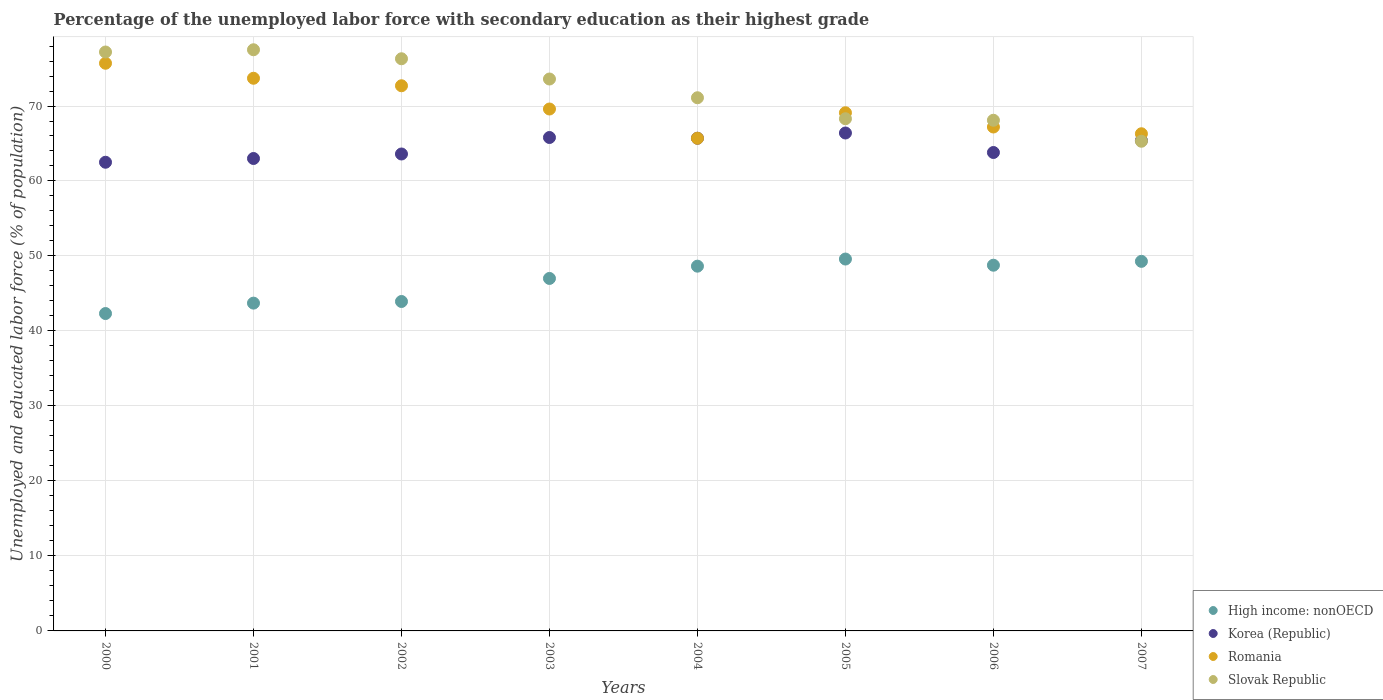What is the percentage of the unemployed labor force with secondary education in Romania in 2005?
Your answer should be very brief. 69.1. Across all years, what is the maximum percentage of the unemployed labor force with secondary education in Romania?
Offer a terse response. 75.7. Across all years, what is the minimum percentage of the unemployed labor force with secondary education in High income: nonOECD?
Your response must be concise. 42.32. In which year was the percentage of the unemployed labor force with secondary education in Korea (Republic) maximum?
Make the answer very short. 2005. In which year was the percentage of the unemployed labor force with secondary education in Romania minimum?
Provide a short and direct response. 2004. What is the total percentage of the unemployed labor force with secondary education in High income: nonOECD in the graph?
Provide a short and direct response. 373.26. What is the difference between the percentage of the unemployed labor force with secondary education in Romania in 2002 and that in 2007?
Your answer should be very brief. 6.4. What is the difference between the percentage of the unemployed labor force with secondary education in Slovak Republic in 2003 and the percentage of the unemployed labor force with secondary education in Korea (Republic) in 2000?
Give a very brief answer. 11.1. What is the average percentage of the unemployed labor force with secondary education in Korea (Republic) per year?
Keep it short and to the point. 64.53. In the year 2005, what is the difference between the percentage of the unemployed labor force with secondary education in Romania and percentage of the unemployed labor force with secondary education in Korea (Republic)?
Offer a terse response. 2.7. What is the ratio of the percentage of the unemployed labor force with secondary education in Korea (Republic) in 2001 to that in 2004?
Ensure brevity in your answer.  0.96. What is the difference between the highest and the second highest percentage of the unemployed labor force with secondary education in Korea (Republic)?
Your answer should be very brief. 0.6. Is the sum of the percentage of the unemployed labor force with secondary education in Romania in 2000 and 2003 greater than the maximum percentage of the unemployed labor force with secondary education in Slovak Republic across all years?
Provide a succinct answer. Yes. Is it the case that in every year, the sum of the percentage of the unemployed labor force with secondary education in Korea (Republic) and percentage of the unemployed labor force with secondary education in High income: nonOECD  is greater than the percentage of the unemployed labor force with secondary education in Romania?
Provide a short and direct response. Yes. Is the percentage of the unemployed labor force with secondary education in Romania strictly greater than the percentage of the unemployed labor force with secondary education in Korea (Republic) over the years?
Your answer should be compact. No. Is the percentage of the unemployed labor force with secondary education in Slovak Republic strictly less than the percentage of the unemployed labor force with secondary education in Romania over the years?
Give a very brief answer. No. How many dotlines are there?
Offer a terse response. 4. What is the difference between two consecutive major ticks on the Y-axis?
Provide a short and direct response. 10. Are the values on the major ticks of Y-axis written in scientific E-notation?
Offer a very short reply. No. What is the title of the graph?
Keep it short and to the point. Percentage of the unemployed labor force with secondary education as their highest grade. What is the label or title of the Y-axis?
Offer a very short reply. Unemployed and educated labor force (% of population). What is the Unemployed and educated labor force (% of population) in High income: nonOECD in 2000?
Make the answer very short. 42.32. What is the Unemployed and educated labor force (% of population) of Korea (Republic) in 2000?
Offer a terse response. 62.5. What is the Unemployed and educated labor force (% of population) in Romania in 2000?
Make the answer very short. 75.7. What is the Unemployed and educated labor force (% of population) in Slovak Republic in 2000?
Provide a short and direct response. 77.2. What is the Unemployed and educated labor force (% of population) in High income: nonOECD in 2001?
Ensure brevity in your answer.  43.71. What is the Unemployed and educated labor force (% of population) in Korea (Republic) in 2001?
Give a very brief answer. 63. What is the Unemployed and educated labor force (% of population) of Romania in 2001?
Give a very brief answer. 73.7. What is the Unemployed and educated labor force (% of population) of Slovak Republic in 2001?
Keep it short and to the point. 77.5. What is the Unemployed and educated labor force (% of population) in High income: nonOECD in 2002?
Your response must be concise. 43.93. What is the Unemployed and educated labor force (% of population) of Korea (Republic) in 2002?
Your response must be concise. 63.6. What is the Unemployed and educated labor force (% of population) in Romania in 2002?
Your answer should be compact. 72.7. What is the Unemployed and educated labor force (% of population) in Slovak Republic in 2002?
Make the answer very short. 76.3. What is the Unemployed and educated labor force (% of population) in High income: nonOECD in 2003?
Ensure brevity in your answer.  47. What is the Unemployed and educated labor force (% of population) of Korea (Republic) in 2003?
Keep it short and to the point. 65.8. What is the Unemployed and educated labor force (% of population) in Romania in 2003?
Provide a short and direct response. 69.6. What is the Unemployed and educated labor force (% of population) of Slovak Republic in 2003?
Offer a very short reply. 73.6. What is the Unemployed and educated labor force (% of population) of High income: nonOECD in 2004?
Provide a succinct answer. 48.64. What is the Unemployed and educated labor force (% of population) of Korea (Republic) in 2004?
Ensure brevity in your answer.  65.7. What is the Unemployed and educated labor force (% of population) of Romania in 2004?
Make the answer very short. 65.7. What is the Unemployed and educated labor force (% of population) in Slovak Republic in 2004?
Ensure brevity in your answer.  71.1. What is the Unemployed and educated labor force (% of population) of High income: nonOECD in 2005?
Offer a very short reply. 49.59. What is the Unemployed and educated labor force (% of population) in Korea (Republic) in 2005?
Offer a terse response. 66.4. What is the Unemployed and educated labor force (% of population) of Romania in 2005?
Offer a very short reply. 69.1. What is the Unemployed and educated labor force (% of population) in Slovak Republic in 2005?
Offer a terse response. 68.3. What is the Unemployed and educated labor force (% of population) of High income: nonOECD in 2006?
Offer a terse response. 48.77. What is the Unemployed and educated labor force (% of population) of Korea (Republic) in 2006?
Give a very brief answer. 63.8. What is the Unemployed and educated labor force (% of population) in Romania in 2006?
Offer a very short reply. 67.2. What is the Unemployed and educated labor force (% of population) of Slovak Republic in 2006?
Offer a very short reply. 68.1. What is the Unemployed and educated labor force (% of population) in High income: nonOECD in 2007?
Offer a terse response. 49.28. What is the Unemployed and educated labor force (% of population) in Korea (Republic) in 2007?
Your response must be concise. 65.4. What is the Unemployed and educated labor force (% of population) of Romania in 2007?
Keep it short and to the point. 66.3. What is the Unemployed and educated labor force (% of population) of Slovak Republic in 2007?
Offer a very short reply. 65.3. Across all years, what is the maximum Unemployed and educated labor force (% of population) of High income: nonOECD?
Give a very brief answer. 49.59. Across all years, what is the maximum Unemployed and educated labor force (% of population) of Korea (Republic)?
Your answer should be compact. 66.4. Across all years, what is the maximum Unemployed and educated labor force (% of population) in Romania?
Ensure brevity in your answer.  75.7. Across all years, what is the maximum Unemployed and educated labor force (% of population) in Slovak Republic?
Ensure brevity in your answer.  77.5. Across all years, what is the minimum Unemployed and educated labor force (% of population) of High income: nonOECD?
Make the answer very short. 42.32. Across all years, what is the minimum Unemployed and educated labor force (% of population) of Korea (Republic)?
Provide a short and direct response. 62.5. Across all years, what is the minimum Unemployed and educated labor force (% of population) in Romania?
Provide a short and direct response. 65.7. Across all years, what is the minimum Unemployed and educated labor force (% of population) in Slovak Republic?
Offer a terse response. 65.3. What is the total Unemployed and educated labor force (% of population) in High income: nonOECD in the graph?
Make the answer very short. 373.26. What is the total Unemployed and educated labor force (% of population) of Korea (Republic) in the graph?
Offer a very short reply. 516.2. What is the total Unemployed and educated labor force (% of population) of Romania in the graph?
Offer a very short reply. 560. What is the total Unemployed and educated labor force (% of population) of Slovak Republic in the graph?
Keep it short and to the point. 577.4. What is the difference between the Unemployed and educated labor force (% of population) of High income: nonOECD in 2000 and that in 2001?
Provide a succinct answer. -1.39. What is the difference between the Unemployed and educated labor force (% of population) in Korea (Republic) in 2000 and that in 2001?
Your answer should be compact. -0.5. What is the difference between the Unemployed and educated labor force (% of population) of Romania in 2000 and that in 2001?
Provide a succinct answer. 2. What is the difference between the Unemployed and educated labor force (% of population) of Slovak Republic in 2000 and that in 2001?
Your answer should be very brief. -0.3. What is the difference between the Unemployed and educated labor force (% of population) of High income: nonOECD in 2000 and that in 2002?
Your answer should be compact. -1.61. What is the difference between the Unemployed and educated labor force (% of population) of Korea (Republic) in 2000 and that in 2002?
Your answer should be compact. -1.1. What is the difference between the Unemployed and educated labor force (% of population) of Romania in 2000 and that in 2002?
Offer a very short reply. 3. What is the difference between the Unemployed and educated labor force (% of population) in High income: nonOECD in 2000 and that in 2003?
Your answer should be very brief. -4.68. What is the difference between the Unemployed and educated labor force (% of population) of Romania in 2000 and that in 2003?
Make the answer very short. 6.1. What is the difference between the Unemployed and educated labor force (% of population) of High income: nonOECD in 2000 and that in 2004?
Give a very brief answer. -6.32. What is the difference between the Unemployed and educated labor force (% of population) of Korea (Republic) in 2000 and that in 2004?
Keep it short and to the point. -3.2. What is the difference between the Unemployed and educated labor force (% of population) of Romania in 2000 and that in 2004?
Provide a succinct answer. 10. What is the difference between the Unemployed and educated labor force (% of population) of Slovak Republic in 2000 and that in 2004?
Ensure brevity in your answer.  6.1. What is the difference between the Unemployed and educated labor force (% of population) of High income: nonOECD in 2000 and that in 2005?
Keep it short and to the point. -7.27. What is the difference between the Unemployed and educated labor force (% of population) of Korea (Republic) in 2000 and that in 2005?
Offer a very short reply. -3.9. What is the difference between the Unemployed and educated labor force (% of population) in High income: nonOECD in 2000 and that in 2006?
Make the answer very short. -6.44. What is the difference between the Unemployed and educated labor force (% of population) in High income: nonOECD in 2000 and that in 2007?
Keep it short and to the point. -6.96. What is the difference between the Unemployed and educated labor force (% of population) in Korea (Republic) in 2000 and that in 2007?
Offer a terse response. -2.9. What is the difference between the Unemployed and educated labor force (% of population) of Slovak Republic in 2000 and that in 2007?
Your response must be concise. 11.9. What is the difference between the Unemployed and educated labor force (% of population) in High income: nonOECD in 2001 and that in 2002?
Offer a terse response. -0.22. What is the difference between the Unemployed and educated labor force (% of population) in Korea (Republic) in 2001 and that in 2002?
Your answer should be very brief. -0.6. What is the difference between the Unemployed and educated labor force (% of population) of Romania in 2001 and that in 2002?
Your answer should be very brief. 1. What is the difference between the Unemployed and educated labor force (% of population) in Slovak Republic in 2001 and that in 2002?
Make the answer very short. 1.2. What is the difference between the Unemployed and educated labor force (% of population) in High income: nonOECD in 2001 and that in 2003?
Your answer should be compact. -3.29. What is the difference between the Unemployed and educated labor force (% of population) of Romania in 2001 and that in 2003?
Make the answer very short. 4.1. What is the difference between the Unemployed and educated labor force (% of population) of Slovak Republic in 2001 and that in 2003?
Your response must be concise. 3.9. What is the difference between the Unemployed and educated labor force (% of population) in High income: nonOECD in 2001 and that in 2004?
Offer a very short reply. -4.93. What is the difference between the Unemployed and educated labor force (% of population) in Korea (Republic) in 2001 and that in 2004?
Give a very brief answer. -2.7. What is the difference between the Unemployed and educated labor force (% of population) of Romania in 2001 and that in 2004?
Your answer should be very brief. 8. What is the difference between the Unemployed and educated labor force (% of population) in Slovak Republic in 2001 and that in 2004?
Your response must be concise. 6.4. What is the difference between the Unemployed and educated labor force (% of population) of High income: nonOECD in 2001 and that in 2005?
Your response must be concise. -5.88. What is the difference between the Unemployed and educated labor force (% of population) of Korea (Republic) in 2001 and that in 2005?
Ensure brevity in your answer.  -3.4. What is the difference between the Unemployed and educated labor force (% of population) of Romania in 2001 and that in 2005?
Give a very brief answer. 4.6. What is the difference between the Unemployed and educated labor force (% of population) of Slovak Republic in 2001 and that in 2005?
Give a very brief answer. 9.2. What is the difference between the Unemployed and educated labor force (% of population) in High income: nonOECD in 2001 and that in 2006?
Your answer should be compact. -5.06. What is the difference between the Unemployed and educated labor force (% of population) in Korea (Republic) in 2001 and that in 2006?
Give a very brief answer. -0.8. What is the difference between the Unemployed and educated labor force (% of population) in Slovak Republic in 2001 and that in 2006?
Provide a succinct answer. 9.4. What is the difference between the Unemployed and educated labor force (% of population) of High income: nonOECD in 2001 and that in 2007?
Your answer should be very brief. -5.57. What is the difference between the Unemployed and educated labor force (% of population) of Romania in 2001 and that in 2007?
Offer a very short reply. 7.4. What is the difference between the Unemployed and educated labor force (% of population) of Slovak Republic in 2001 and that in 2007?
Your answer should be very brief. 12.2. What is the difference between the Unemployed and educated labor force (% of population) of High income: nonOECD in 2002 and that in 2003?
Give a very brief answer. -3.07. What is the difference between the Unemployed and educated labor force (% of population) in Korea (Republic) in 2002 and that in 2003?
Ensure brevity in your answer.  -2.2. What is the difference between the Unemployed and educated labor force (% of population) of Slovak Republic in 2002 and that in 2003?
Provide a succinct answer. 2.7. What is the difference between the Unemployed and educated labor force (% of population) of High income: nonOECD in 2002 and that in 2004?
Your answer should be very brief. -4.71. What is the difference between the Unemployed and educated labor force (% of population) in Korea (Republic) in 2002 and that in 2004?
Make the answer very short. -2.1. What is the difference between the Unemployed and educated labor force (% of population) in Romania in 2002 and that in 2004?
Offer a very short reply. 7. What is the difference between the Unemployed and educated labor force (% of population) of Slovak Republic in 2002 and that in 2004?
Keep it short and to the point. 5.2. What is the difference between the Unemployed and educated labor force (% of population) of High income: nonOECD in 2002 and that in 2005?
Your answer should be very brief. -5.66. What is the difference between the Unemployed and educated labor force (% of population) of Korea (Republic) in 2002 and that in 2005?
Keep it short and to the point. -2.8. What is the difference between the Unemployed and educated labor force (% of population) in Romania in 2002 and that in 2005?
Make the answer very short. 3.6. What is the difference between the Unemployed and educated labor force (% of population) in High income: nonOECD in 2002 and that in 2006?
Give a very brief answer. -4.84. What is the difference between the Unemployed and educated labor force (% of population) in Slovak Republic in 2002 and that in 2006?
Ensure brevity in your answer.  8.2. What is the difference between the Unemployed and educated labor force (% of population) of High income: nonOECD in 2002 and that in 2007?
Provide a short and direct response. -5.35. What is the difference between the Unemployed and educated labor force (% of population) of High income: nonOECD in 2003 and that in 2004?
Your answer should be very brief. -1.64. What is the difference between the Unemployed and educated labor force (% of population) of High income: nonOECD in 2003 and that in 2005?
Give a very brief answer. -2.59. What is the difference between the Unemployed and educated labor force (% of population) of Romania in 2003 and that in 2005?
Give a very brief answer. 0.5. What is the difference between the Unemployed and educated labor force (% of population) in High income: nonOECD in 2003 and that in 2006?
Ensure brevity in your answer.  -1.76. What is the difference between the Unemployed and educated labor force (% of population) of Korea (Republic) in 2003 and that in 2006?
Give a very brief answer. 2. What is the difference between the Unemployed and educated labor force (% of population) of Romania in 2003 and that in 2006?
Your response must be concise. 2.4. What is the difference between the Unemployed and educated labor force (% of population) in High income: nonOECD in 2003 and that in 2007?
Provide a succinct answer. -2.28. What is the difference between the Unemployed and educated labor force (% of population) in Korea (Republic) in 2003 and that in 2007?
Give a very brief answer. 0.4. What is the difference between the Unemployed and educated labor force (% of population) in Slovak Republic in 2003 and that in 2007?
Give a very brief answer. 8.3. What is the difference between the Unemployed and educated labor force (% of population) in High income: nonOECD in 2004 and that in 2005?
Make the answer very short. -0.95. What is the difference between the Unemployed and educated labor force (% of population) in High income: nonOECD in 2004 and that in 2006?
Keep it short and to the point. -0.13. What is the difference between the Unemployed and educated labor force (% of population) of Korea (Republic) in 2004 and that in 2006?
Your answer should be very brief. 1.9. What is the difference between the Unemployed and educated labor force (% of population) of High income: nonOECD in 2004 and that in 2007?
Provide a short and direct response. -0.64. What is the difference between the Unemployed and educated labor force (% of population) of Slovak Republic in 2004 and that in 2007?
Provide a short and direct response. 5.8. What is the difference between the Unemployed and educated labor force (% of population) in High income: nonOECD in 2005 and that in 2006?
Ensure brevity in your answer.  0.82. What is the difference between the Unemployed and educated labor force (% of population) of Romania in 2005 and that in 2006?
Offer a terse response. 1.9. What is the difference between the Unemployed and educated labor force (% of population) of Slovak Republic in 2005 and that in 2006?
Give a very brief answer. 0.2. What is the difference between the Unemployed and educated labor force (% of population) of High income: nonOECD in 2005 and that in 2007?
Your answer should be compact. 0.31. What is the difference between the Unemployed and educated labor force (% of population) of Korea (Republic) in 2005 and that in 2007?
Your response must be concise. 1. What is the difference between the Unemployed and educated labor force (% of population) of High income: nonOECD in 2006 and that in 2007?
Keep it short and to the point. -0.52. What is the difference between the Unemployed and educated labor force (% of population) in Romania in 2006 and that in 2007?
Your answer should be compact. 0.9. What is the difference between the Unemployed and educated labor force (% of population) of High income: nonOECD in 2000 and the Unemployed and educated labor force (% of population) of Korea (Republic) in 2001?
Keep it short and to the point. -20.68. What is the difference between the Unemployed and educated labor force (% of population) of High income: nonOECD in 2000 and the Unemployed and educated labor force (% of population) of Romania in 2001?
Ensure brevity in your answer.  -31.38. What is the difference between the Unemployed and educated labor force (% of population) in High income: nonOECD in 2000 and the Unemployed and educated labor force (% of population) in Slovak Republic in 2001?
Give a very brief answer. -35.18. What is the difference between the Unemployed and educated labor force (% of population) in Romania in 2000 and the Unemployed and educated labor force (% of population) in Slovak Republic in 2001?
Give a very brief answer. -1.8. What is the difference between the Unemployed and educated labor force (% of population) of High income: nonOECD in 2000 and the Unemployed and educated labor force (% of population) of Korea (Republic) in 2002?
Keep it short and to the point. -21.28. What is the difference between the Unemployed and educated labor force (% of population) in High income: nonOECD in 2000 and the Unemployed and educated labor force (% of population) in Romania in 2002?
Provide a succinct answer. -30.38. What is the difference between the Unemployed and educated labor force (% of population) of High income: nonOECD in 2000 and the Unemployed and educated labor force (% of population) of Slovak Republic in 2002?
Provide a short and direct response. -33.98. What is the difference between the Unemployed and educated labor force (% of population) in High income: nonOECD in 2000 and the Unemployed and educated labor force (% of population) in Korea (Republic) in 2003?
Your answer should be very brief. -23.48. What is the difference between the Unemployed and educated labor force (% of population) in High income: nonOECD in 2000 and the Unemployed and educated labor force (% of population) in Romania in 2003?
Keep it short and to the point. -27.28. What is the difference between the Unemployed and educated labor force (% of population) of High income: nonOECD in 2000 and the Unemployed and educated labor force (% of population) of Slovak Republic in 2003?
Offer a very short reply. -31.28. What is the difference between the Unemployed and educated labor force (% of population) in Korea (Republic) in 2000 and the Unemployed and educated labor force (% of population) in Romania in 2003?
Provide a succinct answer. -7.1. What is the difference between the Unemployed and educated labor force (% of population) of Romania in 2000 and the Unemployed and educated labor force (% of population) of Slovak Republic in 2003?
Your answer should be very brief. 2.1. What is the difference between the Unemployed and educated labor force (% of population) in High income: nonOECD in 2000 and the Unemployed and educated labor force (% of population) in Korea (Republic) in 2004?
Make the answer very short. -23.38. What is the difference between the Unemployed and educated labor force (% of population) of High income: nonOECD in 2000 and the Unemployed and educated labor force (% of population) of Romania in 2004?
Offer a very short reply. -23.38. What is the difference between the Unemployed and educated labor force (% of population) in High income: nonOECD in 2000 and the Unemployed and educated labor force (% of population) in Slovak Republic in 2004?
Keep it short and to the point. -28.78. What is the difference between the Unemployed and educated labor force (% of population) in Korea (Republic) in 2000 and the Unemployed and educated labor force (% of population) in Romania in 2004?
Keep it short and to the point. -3.2. What is the difference between the Unemployed and educated labor force (% of population) of Korea (Republic) in 2000 and the Unemployed and educated labor force (% of population) of Slovak Republic in 2004?
Your answer should be compact. -8.6. What is the difference between the Unemployed and educated labor force (% of population) of Romania in 2000 and the Unemployed and educated labor force (% of population) of Slovak Republic in 2004?
Your answer should be compact. 4.6. What is the difference between the Unemployed and educated labor force (% of population) of High income: nonOECD in 2000 and the Unemployed and educated labor force (% of population) of Korea (Republic) in 2005?
Your answer should be compact. -24.08. What is the difference between the Unemployed and educated labor force (% of population) of High income: nonOECD in 2000 and the Unemployed and educated labor force (% of population) of Romania in 2005?
Your answer should be very brief. -26.78. What is the difference between the Unemployed and educated labor force (% of population) in High income: nonOECD in 2000 and the Unemployed and educated labor force (% of population) in Slovak Republic in 2005?
Provide a short and direct response. -25.98. What is the difference between the Unemployed and educated labor force (% of population) in Korea (Republic) in 2000 and the Unemployed and educated labor force (% of population) in Romania in 2005?
Keep it short and to the point. -6.6. What is the difference between the Unemployed and educated labor force (% of population) in Korea (Republic) in 2000 and the Unemployed and educated labor force (% of population) in Slovak Republic in 2005?
Provide a short and direct response. -5.8. What is the difference between the Unemployed and educated labor force (% of population) in Romania in 2000 and the Unemployed and educated labor force (% of population) in Slovak Republic in 2005?
Keep it short and to the point. 7.4. What is the difference between the Unemployed and educated labor force (% of population) of High income: nonOECD in 2000 and the Unemployed and educated labor force (% of population) of Korea (Republic) in 2006?
Your answer should be compact. -21.48. What is the difference between the Unemployed and educated labor force (% of population) of High income: nonOECD in 2000 and the Unemployed and educated labor force (% of population) of Romania in 2006?
Offer a very short reply. -24.88. What is the difference between the Unemployed and educated labor force (% of population) in High income: nonOECD in 2000 and the Unemployed and educated labor force (% of population) in Slovak Republic in 2006?
Your answer should be compact. -25.78. What is the difference between the Unemployed and educated labor force (% of population) in Korea (Republic) in 2000 and the Unemployed and educated labor force (% of population) in Romania in 2006?
Give a very brief answer. -4.7. What is the difference between the Unemployed and educated labor force (% of population) in Korea (Republic) in 2000 and the Unemployed and educated labor force (% of population) in Slovak Republic in 2006?
Provide a succinct answer. -5.6. What is the difference between the Unemployed and educated labor force (% of population) in Romania in 2000 and the Unemployed and educated labor force (% of population) in Slovak Republic in 2006?
Ensure brevity in your answer.  7.6. What is the difference between the Unemployed and educated labor force (% of population) of High income: nonOECD in 2000 and the Unemployed and educated labor force (% of population) of Korea (Republic) in 2007?
Provide a succinct answer. -23.08. What is the difference between the Unemployed and educated labor force (% of population) of High income: nonOECD in 2000 and the Unemployed and educated labor force (% of population) of Romania in 2007?
Offer a terse response. -23.98. What is the difference between the Unemployed and educated labor force (% of population) in High income: nonOECD in 2000 and the Unemployed and educated labor force (% of population) in Slovak Republic in 2007?
Your answer should be compact. -22.98. What is the difference between the Unemployed and educated labor force (% of population) of High income: nonOECD in 2001 and the Unemployed and educated labor force (% of population) of Korea (Republic) in 2002?
Ensure brevity in your answer.  -19.89. What is the difference between the Unemployed and educated labor force (% of population) of High income: nonOECD in 2001 and the Unemployed and educated labor force (% of population) of Romania in 2002?
Give a very brief answer. -28.99. What is the difference between the Unemployed and educated labor force (% of population) of High income: nonOECD in 2001 and the Unemployed and educated labor force (% of population) of Slovak Republic in 2002?
Your answer should be very brief. -32.59. What is the difference between the Unemployed and educated labor force (% of population) of Korea (Republic) in 2001 and the Unemployed and educated labor force (% of population) of Slovak Republic in 2002?
Provide a short and direct response. -13.3. What is the difference between the Unemployed and educated labor force (% of population) of High income: nonOECD in 2001 and the Unemployed and educated labor force (% of population) of Korea (Republic) in 2003?
Your answer should be very brief. -22.09. What is the difference between the Unemployed and educated labor force (% of population) in High income: nonOECD in 2001 and the Unemployed and educated labor force (% of population) in Romania in 2003?
Make the answer very short. -25.89. What is the difference between the Unemployed and educated labor force (% of population) in High income: nonOECD in 2001 and the Unemployed and educated labor force (% of population) in Slovak Republic in 2003?
Your response must be concise. -29.89. What is the difference between the Unemployed and educated labor force (% of population) of Korea (Republic) in 2001 and the Unemployed and educated labor force (% of population) of Romania in 2003?
Offer a terse response. -6.6. What is the difference between the Unemployed and educated labor force (% of population) in High income: nonOECD in 2001 and the Unemployed and educated labor force (% of population) in Korea (Republic) in 2004?
Make the answer very short. -21.99. What is the difference between the Unemployed and educated labor force (% of population) in High income: nonOECD in 2001 and the Unemployed and educated labor force (% of population) in Romania in 2004?
Ensure brevity in your answer.  -21.99. What is the difference between the Unemployed and educated labor force (% of population) in High income: nonOECD in 2001 and the Unemployed and educated labor force (% of population) in Slovak Republic in 2004?
Your response must be concise. -27.39. What is the difference between the Unemployed and educated labor force (% of population) of High income: nonOECD in 2001 and the Unemployed and educated labor force (% of population) of Korea (Republic) in 2005?
Give a very brief answer. -22.69. What is the difference between the Unemployed and educated labor force (% of population) in High income: nonOECD in 2001 and the Unemployed and educated labor force (% of population) in Romania in 2005?
Provide a short and direct response. -25.39. What is the difference between the Unemployed and educated labor force (% of population) in High income: nonOECD in 2001 and the Unemployed and educated labor force (% of population) in Slovak Republic in 2005?
Offer a very short reply. -24.59. What is the difference between the Unemployed and educated labor force (% of population) in High income: nonOECD in 2001 and the Unemployed and educated labor force (% of population) in Korea (Republic) in 2006?
Ensure brevity in your answer.  -20.09. What is the difference between the Unemployed and educated labor force (% of population) in High income: nonOECD in 2001 and the Unemployed and educated labor force (% of population) in Romania in 2006?
Offer a very short reply. -23.49. What is the difference between the Unemployed and educated labor force (% of population) in High income: nonOECD in 2001 and the Unemployed and educated labor force (% of population) in Slovak Republic in 2006?
Offer a very short reply. -24.39. What is the difference between the Unemployed and educated labor force (% of population) in Korea (Republic) in 2001 and the Unemployed and educated labor force (% of population) in Romania in 2006?
Make the answer very short. -4.2. What is the difference between the Unemployed and educated labor force (% of population) of Korea (Republic) in 2001 and the Unemployed and educated labor force (% of population) of Slovak Republic in 2006?
Your response must be concise. -5.1. What is the difference between the Unemployed and educated labor force (% of population) in Romania in 2001 and the Unemployed and educated labor force (% of population) in Slovak Republic in 2006?
Make the answer very short. 5.6. What is the difference between the Unemployed and educated labor force (% of population) in High income: nonOECD in 2001 and the Unemployed and educated labor force (% of population) in Korea (Republic) in 2007?
Your answer should be compact. -21.69. What is the difference between the Unemployed and educated labor force (% of population) in High income: nonOECD in 2001 and the Unemployed and educated labor force (% of population) in Romania in 2007?
Ensure brevity in your answer.  -22.59. What is the difference between the Unemployed and educated labor force (% of population) of High income: nonOECD in 2001 and the Unemployed and educated labor force (% of population) of Slovak Republic in 2007?
Keep it short and to the point. -21.59. What is the difference between the Unemployed and educated labor force (% of population) in Korea (Republic) in 2001 and the Unemployed and educated labor force (% of population) in Romania in 2007?
Ensure brevity in your answer.  -3.3. What is the difference between the Unemployed and educated labor force (% of population) of Korea (Republic) in 2001 and the Unemployed and educated labor force (% of population) of Slovak Republic in 2007?
Your answer should be very brief. -2.3. What is the difference between the Unemployed and educated labor force (% of population) in Romania in 2001 and the Unemployed and educated labor force (% of population) in Slovak Republic in 2007?
Give a very brief answer. 8.4. What is the difference between the Unemployed and educated labor force (% of population) in High income: nonOECD in 2002 and the Unemployed and educated labor force (% of population) in Korea (Republic) in 2003?
Your response must be concise. -21.87. What is the difference between the Unemployed and educated labor force (% of population) in High income: nonOECD in 2002 and the Unemployed and educated labor force (% of population) in Romania in 2003?
Your answer should be very brief. -25.67. What is the difference between the Unemployed and educated labor force (% of population) in High income: nonOECD in 2002 and the Unemployed and educated labor force (% of population) in Slovak Republic in 2003?
Offer a very short reply. -29.67. What is the difference between the Unemployed and educated labor force (% of population) of Korea (Republic) in 2002 and the Unemployed and educated labor force (% of population) of Romania in 2003?
Keep it short and to the point. -6. What is the difference between the Unemployed and educated labor force (% of population) of Korea (Republic) in 2002 and the Unemployed and educated labor force (% of population) of Slovak Republic in 2003?
Your answer should be very brief. -10. What is the difference between the Unemployed and educated labor force (% of population) of High income: nonOECD in 2002 and the Unemployed and educated labor force (% of population) of Korea (Republic) in 2004?
Your answer should be very brief. -21.77. What is the difference between the Unemployed and educated labor force (% of population) in High income: nonOECD in 2002 and the Unemployed and educated labor force (% of population) in Romania in 2004?
Provide a succinct answer. -21.77. What is the difference between the Unemployed and educated labor force (% of population) in High income: nonOECD in 2002 and the Unemployed and educated labor force (% of population) in Slovak Republic in 2004?
Offer a terse response. -27.17. What is the difference between the Unemployed and educated labor force (% of population) of Korea (Republic) in 2002 and the Unemployed and educated labor force (% of population) of Romania in 2004?
Give a very brief answer. -2.1. What is the difference between the Unemployed and educated labor force (% of population) in Korea (Republic) in 2002 and the Unemployed and educated labor force (% of population) in Slovak Republic in 2004?
Offer a terse response. -7.5. What is the difference between the Unemployed and educated labor force (% of population) in High income: nonOECD in 2002 and the Unemployed and educated labor force (% of population) in Korea (Republic) in 2005?
Your answer should be very brief. -22.47. What is the difference between the Unemployed and educated labor force (% of population) of High income: nonOECD in 2002 and the Unemployed and educated labor force (% of population) of Romania in 2005?
Keep it short and to the point. -25.17. What is the difference between the Unemployed and educated labor force (% of population) of High income: nonOECD in 2002 and the Unemployed and educated labor force (% of population) of Slovak Republic in 2005?
Your answer should be very brief. -24.37. What is the difference between the Unemployed and educated labor force (% of population) in Korea (Republic) in 2002 and the Unemployed and educated labor force (% of population) in Romania in 2005?
Give a very brief answer. -5.5. What is the difference between the Unemployed and educated labor force (% of population) of Korea (Republic) in 2002 and the Unemployed and educated labor force (% of population) of Slovak Republic in 2005?
Provide a succinct answer. -4.7. What is the difference between the Unemployed and educated labor force (% of population) of High income: nonOECD in 2002 and the Unemployed and educated labor force (% of population) of Korea (Republic) in 2006?
Your answer should be very brief. -19.87. What is the difference between the Unemployed and educated labor force (% of population) of High income: nonOECD in 2002 and the Unemployed and educated labor force (% of population) of Romania in 2006?
Your response must be concise. -23.27. What is the difference between the Unemployed and educated labor force (% of population) in High income: nonOECD in 2002 and the Unemployed and educated labor force (% of population) in Slovak Republic in 2006?
Your answer should be compact. -24.17. What is the difference between the Unemployed and educated labor force (% of population) of High income: nonOECD in 2002 and the Unemployed and educated labor force (% of population) of Korea (Republic) in 2007?
Offer a terse response. -21.47. What is the difference between the Unemployed and educated labor force (% of population) of High income: nonOECD in 2002 and the Unemployed and educated labor force (% of population) of Romania in 2007?
Offer a terse response. -22.37. What is the difference between the Unemployed and educated labor force (% of population) of High income: nonOECD in 2002 and the Unemployed and educated labor force (% of population) of Slovak Republic in 2007?
Make the answer very short. -21.37. What is the difference between the Unemployed and educated labor force (% of population) in Romania in 2002 and the Unemployed and educated labor force (% of population) in Slovak Republic in 2007?
Give a very brief answer. 7.4. What is the difference between the Unemployed and educated labor force (% of population) of High income: nonOECD in 2003 and the Unemployed and educated labor force (% of population) of Korea (Republic) in 2004?
Ensure brevity in your answer.  -18.7. What is the difference between the Unemployed and educated labor force (% of population) in High income: nonOECD in 2003 and the Unemployed and educated labor force (% of population) in Romania in 2004?
Provide a succinct answer. -18.7. What is the difference between the Unemployed and educated labor force (% of population) of High income: nonOECD in 2003 and the Unemployed and educated labor force (% of population) of Slovak Republic in 2004?
Your answer should be compact. -24.1. What is the difference between the Unemployed and educated labor force (% of population) in Korea (Republic) in 2003 and the Unemployed and educated labor force (% of population) in Slovak Republic in 2004?
Offer a very short reply. -5.3. What is the difference between the Unemployed and educated labor force (% of population) in High income: nonOECD in 2003 and the Unemployed and educated labor force (% of population) in Korea (Republic) in 2005?
Your answer should be very brief. -19.4. What is the difference between the Unemployed and educated labor force (% of population) in High income: nonOECD in 2003 and the Unemployed and educated labor force (% of population) in Romania in 2005?
Offer a very short reply. -22.1. What is the difference between the Unemployed and educated labor force (% of population) in High income: nonOECD in 2003 and the Unemployed and educated labor force (% of population) in Slovak Republic in 2005?
Your response must be concise. -21.3. What is the difference between the Unemployed and educated labor force (% of population) of Korea (Republic) in 2003 and the Unemployed and educated labor force (% of population) of Romania in 2005?
Your response must be concise. -3.3. What is the difference between the Unemployed and educated labor force (% of population) of Korea (Republic) in 2003 and the Unemployed and educated labor force (% of population) of Slovak Republic in 2005?
Offer a terse response. -2.5. What is the difference between the Unemployed and educated labor force (% of population) of High income: nonOECD in 2003 and the Unemployed and educated labor force (% of population) of Korea (Republic) in 2006?
Provide a succinct answer. -16.8. What is the difference between the Unemployed and educated labor force (% of population) in High income: nonOECD in 2003 and the Unemployed and educated labor force (% of population) in Romania in 2006?
Give a very brief answer. -20.2. What is the difference between the Unemployed and educated labor force (% of population) in High income: nonOECD in 2003 and the Unemployed and educated labor force (% of population) in Slovak Republic in 2006?
Your response must be concise. -21.1. What is the difference between the Unemployed and educated labor force (% of population) in Romania in 2003 and the Unemployed and educated labor force (% of population) in Slovak Republic in 2006?
Your answer should be very brief. 1.5. What is the difference between the Unemployed and educated labor force (% of population) in High income: nonOECD in 2003 and the Unemployed and educated labor force (% of population) in Korea (Republic) in 2007?
Make the answer very short. -18.4. What is the difference between the Unemployed and educated labor force (% of population) in High income: nonOECD in 2003 and the Unemployed and educated labor force (% of population) in Romania in 2007?
Ensure brevity in your answer.  -19.3. What is the difference between the Unemployed and educated labor force (% of population) in High income: nonOECD in 2003 and the Unemployed and educated labor force (% of population) in Slovak Republic in 2007?
Your response must be concise. -18.3. What is the difference between the Unemployed and educated labor force (% of population) in Korea (Republic) in 2003 and the Unemployed and educated labor force (% of population) in Romania in 2007?
Keep it short and to the point. -0.5. What is the difference between the Unemployed and educated labor force (% of population) of Romania in 2003 and the Unemployed and educated labor force (% of population) of Slovak Republic in 2007?
Give a very brief answer. 4.3. What is the difference between the Unemployed and educated labor force (% of population) in High income: nonOECD in 2004 and the Unemployed and educated labor force (% of population) in Korea (Republic) in 2005?
Provide a succinct answer. -17.76. What is the difference between the Unemployed and educated labor force (% of population) of High income: nonOECD in 2004 and the Unemployed and educated labor force (% of population) of Romania in 2005?
Make the answer very short. -20.46. What is the difference between the Unemployed and educated labor force (% of population) in High income: nonOECD in 2004 and the Unemployed and educated labor force (% of population) in Slovak Republic in 2005?
Offer a terse response. -19.66. What is the difference between the Unemployed and educated labor force (% of population) in Korea (Republic) in 2004 and the Unemployed and educated labor force (% of population) in Slovak Republic in 2005?
Your answer should be compact. -2.6. What is the difference between the Unemployed and educated labor force (% of population) of Romania in 2004 and the Unemployed and educated labor force (% of population) of Slovak Republic in 2005?
Your answer should be very brief. -2.6. What is the difference between the Unemployed and educated labor force (% of population) of High income: nonOECD in 2004 and the Unemployed and educated labor force (% of population) of Korea (Republic) in 2006?
Your answer should be very brief. -15.16. What is the difference between the Unemployed and educated labor force (% of population) of High income: nonOECD in 2004 and the Unemployed and educated labor force (% of population) of Romania in 2006?
Give a very brief answer. -18.56. What is the difference between the Unemployed and educated labor force (% of population) of High income: nonOECD in 2004 and the Unemployed and educated labor force (% of population) of Slovak Republic in 2006?
Your answer should be compact. -19.46. What is the difference between the Unemployed and educated labor force (% of population) of Korea (Republic) in 2004 and the Unemployed and educated labor force (% of population) of Slovak Republic in 2006?
Your answer should be compact. -2.4. What is the difference between the Unemployed and educated labor force (% of population) in Romania in 2004 and the Unemployed and educated labor force (% of population) in Slovak Republic in 2006?
Keep it short and to the point. -2.4. What is the difference between the Unemployed and educated labor force (% of population) in High income: nonOECD in 2004 and the Unemployed and educated labor force (% of population) in Korea (Republic) in 2007?
Offer a very short reply. -16.76. What is the difference between the Unemployed and educated labor force (% of population) of High income: nonOECD in 2004 and the Unemployed and educated labor force (% of population) of Romania in 2007?
Offer a terse response. -17.66. What is the difference between the Unemployed and educated labor force (% of population) of High income: nonOECD in 2004 and the Unemployed and educated labor force (% of population) of Slovak Republic in 2007?
Ensure brevity in your answer.  -16.66. What is the difference between the Unemployed and educated labor force (% of population) of Romania in 2004 and the Unemployed and educated labor force (% of population) of Slovak Republic in 2007?
Your answer should be very brief. 0.4. What is the difference between the Unemployed and educated labor force (% of population) of High income: nonOECD in 2005 and the Unemployed and educated labor force (% of population) of Korea (Republic) in 2006?
Make the answer very short. -14.21. What is the difference between the Unemployed and educated labor force (% of population) of High income: nonOECD in 2005 and the Unemployed and educated labor force (% of population) of Romania in 2006?
Offer a very short reply. -17.61. What is the difference between the Unemployed and educated labor force (% of population) of High income: nonOECD in 2005 and the Unemployed and educated labor force (% of population) of Slovak Republic in 2006?
Your answer should be compact. -18.51. What is the difference between the Unemployed and educated labor force (% of population) in Korea (Republic) in 2005 and the Unemployed and educated labor force (% of population) in Slovak Republic in 2006?
Give a very brief answer. -1.7. What is the difference between the Unemployed and educated labor force (% of population) in Romania in 2005 and the Unemployed and educated labor force (% of population) in Slovak Republic in 2006?
Make the answer very short. 1. What is the difference between the Unemployed and educated labor force (% of population) of High income: nonOECD in 2005 and the Unemployed and educated labor force (% of population) of Korea (Republic) in 2007?
Keep it short and to the point. -15.81. What is the difference between the Unemployed and educated labor force (% of population) of High income: nonOECD in 2005 and the Unemployed and educated labor force (% of population) of Romania in 2007?
Give a very brief answer. -16.71. What is the difference between the Unemployed and educated labor force (% of population) of High income: nonOECD in 2005 and the Unemployed and educated labor force (% of population) of Slovak Republic in 2007?
Give a very brief answer. -15.71. What is the difference between the Unemployed and educated labor force (% of population) of Korea (Republic) in 2005 and the Unemployed and educated labor force (% of population) of Romania in 2007?
Your response must be concise. 0.1. What is the difference between the Unemployed and educated labor force (% of population) of High income: nonOECD in 2006 and the Unemployed and educated labor force (% of population) of Korea (Republic) in 2007?
Ensure brevity in your answer.  -16.63. What is the difference between the Unemployed and educated labor force (% of population) in High income: nonOECD in 2006 and the Unemployed and educated labor force (% of population) in Romania in 2007?
Offer a terse response. -17.53. What is the difference between the Unemployed and educated labor force (% of population) of High income: nonOECD in 2006 and the Unemployed and educated labor force (% of population) of Slovak Republic in 2007?
Offer a very short reply. -16.53. What is the difference between the Unemployed and educated labor force (% of population) of Korea (Republic) in 2006 and the Unemployed and educated labor force (% of population) of Romania in 2007?
Your answer should be compact. -2.5. What is the difference between the Unemployed and educated labor force (% of population) of Romania in 2006 and the Unemployed and educated labor force (% of population) of Slovak Republic in 2007?
Make the answer very short. 1.9. What is the average Unemployed and educated labor force (% of population) of High income: nonOECD per year?
Provide a succinct answer. 46.66. What is the average Unemployed and educated labor force (% of population) of Korea (Republic) per year?
Your answer should be compact. 64.53. What is the average Unemployed and educated labor force (% of population) of Slovak Republic per year?
Provide a short and direct response. 72.17. In the year 2000, what is the difference between the Unemployed and educated labor force (% of population) in High income: nonOECD and Unemployed and educated labor force (% of population) in Korea (Republic)?
Your answer should be very brief. -20.18. In the year 2000, what is the difference between the Unemployed and educated labor force (% of population) of High income: nonOECD and Unemployed and educated labor force (% of population) of Romania?
Your answer should be compact. -33.38. In the year 2000, what is the difference between the Unemployed and educated labor force (% of population) of High income: nonOECD and Unemployed and educated labor force (% of population) of Slovak Republic?
Your answer should be very brief. -34.88. In the year 2000, what is the difference between the Unemployed and educated labor force (% of population) of Korea (Republic) and Unemployed and educated labor force (% of population) of Romania?
Keep it short and to the point. -13.2. In the year 2000, what is the difference between the Unemployed and educated labor force (% of population) of Korea (Republic) and Unemployed and educated labor force (% of population) of Slovak Republic?
Offer a very short reply. -14.7. In the year 2001, what is the difference between the Unemployed and educated labor force (% of population) of High income: nonOECD and Unemployed and educated labor force (% of population) of Korea (Republic)?
Your answer should be compact. -19.29. In the year 2001, what is the difference between the Unemployed and educated labor force (% of population) in High income: nonOECD and Unemployed and educated labor force (% of population) in Romania?
Provide a succinct answer. -29.99. In the year 2001, what is the difference between the Unemployed and educated labor force (% of population) of High income: nonOECD and Unemployed and educated labor force (% of population) of Slovak Republic?
Provide a short and direct response. -33.79. In the year 2001, what is the difference between the Unemployed and educated labor force (% of population) in Korea (Republic) and Unemployed and educated labor force (% of population) in Slovak Republic?
Offer a terse response. -14.5. In the year 2002, what is the difference between the Unemployed and educated labor force (% of population) in High income: nonOECD and Unemployed and educated labor force (% of population) in Korea (Republic)?
Ensure brevity in your answer.  -19.67. In the year 2002, what is the difference between the Unemployed and educated labor force (% of population) in High income: nonOECD and Unemployed and educated labor force (% of population) in Romania?
Offer a very short reply. -28.77. In the year 2002, what is the difference between the Unemployed and educated labor force (% of population) of High income: nonOECD and Unemployed and educated labor force (% of population) of Slovak Republic?
Offer a terse response. -32.37. In the year 2002, what is the difference between the Unemployed and educated labor force (% of population) in Romania and Unemployed and educated labor force (% of population) in Slovak Republic?
Ensure brevity in your answer.  -3.6. In the year 2003, what is the difference between the Unemployed and educated labor force (% of population) of High income: nonOECD and Unemployed and educated labor force (% of population) of Korea (Republic)?
Offer a very short reply. -18.8. In the year 2003, what is the difference between the Unemployed and educated labor force (% of population) of High income: nonOECD and Unemployed and educated labor force (% of population) of Romania?
Ensure brevity in your answer.  -22.6. In the year 2003, what is the difference between the Unemployed and educated labor force (% of population) in High income: nonOECD and Unemployed and educated labor force (% of population) in Slovak Republic?
Offer a very short reply. -26.6. In the year 2003, what is the difference between the Unemployed and educated labor force (% of population) in Korea (Republic) and Unemployed and educated labor force (% of population) in Slovak Republic?
Your answer should be compact. -7.8. In the year 2003, what is the difference between the Unemployed and educated labor force (% of population) in Romania and Unemployed and educated labor force (% of population) in Slovak Republic?
Your response must be concise. -4. In the year 2004, what is the difference between the Unemployed and educated labor force (% of population) of High income: nonOECD and Unemployed and educated labor force (% of population) of Korea (Republic)?
Make the answer very short. -17.06. In the year 2004, what is the difference between the Unemployed and educated labor force (% of population) of High income: nonOECD and Unemployed and educated labor force (% of population) of Romania?
Give a very brief answer. -17.06. In the year 2004, what is the difference between the Unemployed and educated labor force (% of population) in High income: nonOECD and Unemployed and educated labor force (% of population) in Slovak Republic?
Offer a very short reply. -22.46. In the year 2005, what is the difference between the Unemployed and educated labor force (% of population) in High income: nonOECD and Unemployed and educated labor force (% of population) in Korea (Republic)?
Your answer should be very brief. -16.81. In the year 2005, what is the difference between the Unemployed and educated labor force (% of population) of High income: nonOECD and Unemployed and educated labor force (% of population) of Romania?
Keep it short and to the point. -19.51. In the year 2005, what is the difference between the Unemployed and educated labor force (% of population) in High income: nonOECD and Unemployed and educated labor force (% of population) in Slovak Republic?
Ensure brevity in your answer.  -18.71. In the year 2005, what is the difference between the Unemployed and educated labor force (% of population) in Korea (Republic) and Unemployed and educated labor force (% of population) in Slovak Republic?
Keep it short and to the point. -1.9. In the year 2006, what is the difference between the Unemployed and educated labor force (% of population) of High income: nonOECD and Unemployed and educated labor force (% of population) of Korea (Republic)?
Offer a very short reply. -15.03. In the year 2006, what is the difference between the Unemployed and educated labor force (% of population) of High income: nonOECD and Unemployed and educated labor force (% of population) of Romania?
Your answer should be very brief. -18.43. In the year 2006, what is the difference between the Unemployed and educated labor force (% of population) in High income: nonOECD and Unemployed and educated labor force (% of population) in Slovak Republic?
Ensure brevity in your answer.  -19.33. In the year 2006, what is the difference between the Unemployed and educated labor force (% of population) in Korea (Republic) and Unemployed and educated labor force (% of population) in Slovak Republic?
Your answer should be compact. -4.3. In the year 2007, what is the difference between the Unemployed and educated labor force (% of population) of High income: nonOECD and Unemployed and educated labor force (% of population) of Korea (Republic)?
Provide a succinct answer. -16.12. In the year 2007, what is the difference between the Unemployed and educated labor force (% of population) of High income: nonOECD and Unemployed and educated labor force (% of population) of Romania?
Give a very brief answer. -17.02. In the year 2007, what is the difference between the Unemployed and educated labor force (% of population) in High income: nonOECD and Unemployed and educated labor force (% of population) in Slovak Republic?
Keep it short and to the point. -16.02. In the year 2007, what is the difference between the Unemployed and educated labor force (% of population) in Korea (Republic) and Unemployed and educated labor force (% of population) in Romania?
Keep it short and to the point. -0.9. In the year 2007, what is the difference between the Unemployed and educated labor force (% of population) of Korea (Republic) and Unemployed and educated labor force (% of population) of Slovak Republic?
Ensure brevity in your answer.  0.1. What is the ratio of the Unemployed and educated labor force (% of population) in High income: nonOECD in 2000 to that in 2001?
Keep it short and to the point. 0.97. What is the ratio of the Unemployed and educated labor force (% of population) of Romania in 2000 to that in 2001?
Offer a terse response. 1.03. What is the ratio of the Unemployed and educated labor force (% of population) in High income: nonOECD in 2000 to that in 2002?
Offer a terse response. 0.96. What is the ratio of the Unemployed and educated labor force (% of population) in Korea (Republic) in 2000 to that in 2002?
Ensure brevity in your answer.  0.98. What is the ratio of the Unemployed and educated labor force (% of population) in Romania in 2000 to that in 2002?
Ensure brevity in your answer.  1.04. What is the ratio of the Unemployed and educated labor force (% of population) in Slovak Republic in 2000 to that in 2002?
Your response must be concise. 1.01. What is the ratio of the Unemployed and educated labor force (% of population) in High income: nonOECD in 2000 to that in 2003?
Provide a short and direct response. 0.9. What is the ratio of the Unemployed and educated labor force (% of population) in Korea (Republic) in 2000 to that in 2003?
Provide a short and direct response. 0.95. What is the ratio of the Unemployed and educated labor force (% of population) in Romania in 2000 to that in 2003?
Give a very brief answer. 1.09. What is the ratio of the Unemployed and educated labor force (% of population) of Slovak Republic in 2000 to that in 2003?
Provide a succinct answer. 1.05. What is the ratio of the Unemployed and educated labor force (% of population) of High income: nonOECD in 2000 to that in 2004?
Your answer should be very brief. 0.87. What is the ratio of the Unemployed and educated labor force (% of population) of Korea (Republic) in 2000 to that in 2004?
Provide a succinct answer. 0.95. What is the ratio of the Unemployed and educated labor force (% of population) of Romania in 2000 to that in 2004?
Offer a very short reply. 1.15. What is the ratio of the Unemployed and educated labor force (% of population) of Slovak Republic in 2000 to that in 2004?
Keep it short and to the point. 1.09. What is the ratio of the Unemployed and educated labor force (% of population) of High income: nonOECD in 2000 to that in 2005?
Provide a succinct answer. 0.85. What is the ratio of the Unemployed and educated labor force (% of population) in Korea (Republic) in 2000 to that in 2005?
Offer a very short reply. 0.94. What is the ratio of the Unemployed and educated labor force (% of population) in Romania in 2000 to that in 2005?
Offer a very short reply. 1.1. What is the ratio of the Unemployed and educated labor force (% of population) in Slovak Republic in 2000 to that in 2005?
Your answer should be compact. 1.13. What is the ratio of the Unemployed and educated labor force (% of population) of High income: nonOECD in 2000 to that in 2006?
Your answer should be compact. 0.87. What is the ratio of the Unemployed and educated labor force (% of population) in Korea (Republic) in 2000 to that in 2006?
Your response must be concise. 0.98. What is the ratio of the Unemployed and educated labor force (% of population) of Romania in 2000 to that in 2006?
Provide a short and direct response. 1.13. What is the ratio of the Unemployed and educated labor force (% of population) in Slovak Republic in 2000 to that in 2006?
Your answer should be compact. 1.13. What is the ratio of the Unemployed and educated labor force (% of population) in High income: nonOECD in 2000 to that in 2007?
Offer a very short reply. 0.86. What is the ratio of the Unemployed and educated labor force (% of population) in Korea (Republic) in 2000 to that in 2007?
Provide a short and direct response. 0.96. What is the ratio of the Unemployed and educated labor force (% of population) in Romania in 2000 to that in 2007?
Make the answer very short. 1.14. What is the ratio of the Unemployed and educated labor force (% of population) in Slovak Republic in 2000 to that in 2007?
Offer a terse response. 1.18. What is the ratio of the Unemployed and educated labor force (% of population) in Korea (Republic) in 2001 to that in 2002?
Give a very brief answer. 0.99. What is the ratio of the Unemployed and educated labor force (% of population) in Romania in 2001 to that in 2002?
Your response must be concise. 1.01. What is the ratio of the Unemployed and educated labor force (% of population) in Slovak Republic in 2001 to that in 2002?
Keep it short and to the point. 1.02. What is the ratio of the Unemployed and educated labor force (% of population) of High income: nonOECD in 2001 to that in 2003?
Your response must be concise. 0.93. What is the ratio of the Unemployed and educated labor force (% of population) in Korea (Republic) in 2001 to that in 2003?
Provide a succinct answer. 0.96. What is the ratio of the Unemployed and educated labor force (% of population) of Romania in 2001 to that in 2003?
Ensure brevity in your answer.  1.06. What is the ratio of the Unemployed and educated labor force (% of population) in Slovak Republic in 2001 to that in 2003?
Provide a succinct answer. 1.05. What is the ratio of the Unemployed and educated labor force (% of population) in High income: nonOECD in 2001 to that in 2004?
Give a very brief answer. 0.9. What is the ratio of the Unemployed and educated labor force (% of population) of Korea (Republic) in 2001 to that in 2004?
Offer a terse response. 0.96. What is the ratio of the Unemployed and educated labor force (% of population) in Romania in 2001 to that in 2004?
Provide a short and direct response. 1.12. What is the ratio of the Unemployed and educated labor force (% of population) in Slovak Republic in 2001 to that in 2004?
Offer a terse response. 1.09. What is the ratio of the Unemployed and educated labor force (% of population) in High income: nonOECD in 2001 to that in 2005?
Your answer should be compact. 0.88. What is the ratio of the Unemployed and educated labor force (% of population) in Korea (Republic) in 2001 to that in 2005?
Make the answer very short. 0.95. What is the ratio of the Unemployed and educated labor force (% of population) of Romania in 2001 to that in 2005?
Give a very brief answer. 1.07. What is the ratio of the Unemployed and educated labor force (% of population) of Slovak Republic in 2001 to that in 2005?
Offer a terse response. 1.13. What is the ratio of the Unemployed and educated labor force (% of population) in High income: nonOECD in 2001 to that in 2006?
Provide a short and direct response. 0.9. What is the ratio of the Unemployed and educated labor force (% of population) of Korea (Republic) in 2001 to that in 2006?
Ensure brevity in your answer.  0.99. What is the ratio of the Unemployed and educated labor force (% of population) of Romania in 2001 to that in 2006?
Offer a terse response. 1.1. What is the ratio of the Unemployed and educated labor force (% of population) of Slovak Republic in 2001 to that in 2006?
Ensure brevity in your answer.  1.14. What is the ratio of the Unemployed and educated labor force (% of population) in High income: nonOECD in 2001 to that in 2007?
Keep it short and to the point. 0.89. What is the ratio of the Unemployed and educated labor force (% of population) in Korea (Republic) in 2001 to that in 2007?
Provide a succinct answer. 0.96. What is the ratio of the Unemployed and educated labor force (% of population) in Romania in 2001 to that in 2007?
Offer a very short reply. 1.11. What is the ratio of the Unemployed and educated labor force (% of population) of Slovak Republic in 2001 to that in 2007?
Offer a very short reply. 1.19. What is the ratio of the Unemployed and educated labor force (% of population) of High income: nonOECD in 2002 to that in 2003?
Give a very brief answer. 0.93. What is the ratio of the Unemployed and educated labor force (% of population) of Korea (Republic) in 2002 to that in 2003?
Your response must be concise. 0.97. What is the ratio of the Unemployed and educated labor force (% of population) in Romania in 2002 to that in 2003?
Provide a succinct answer. 1.04. What is the ratio of the Unemployed and educated labor force (% of population) in Slovak Republic in 2002 to that in 2003?
Your response must be concise. 1.04. What is the ratio of the Unemployed and educated labor force (% of population) of High income: nonOECD in 2002 to that in 2004?
Your answer should be very brief. 0.9. What is the ratio of the Unemployed and educated labor force (% of population) of Romania in 2002 to that in 2004?
Your answer should be compact. 1.11. What is the ratio of the Unemployed and educated labor force (% of population) in Slovak Republic in 2002 to that in 2004?
Provide a succinct answer. 1.07. What is the ratio of the Unemployed and educated labor force (% of population) in High income: nonOECD in 2002 to that in 2005?
Offer a terse response. 0.89. What is the ratio of the Unemployed and educated labor force (% of population) in Korea (Republic) in 2002 to that in 2005?
Ensure brevity in your answer.  0.96. What is the ratio of the Unemployed and educated labor force (% of population) of Romania in 2002 to that in 2005?
Make the answer very short. 1.05. What is the ratio of the Unemployed and educated labor force (% of population) of Slovak Republic in 2002 to that in 2005?
Ensure brevity in your answer.  1.12. What is the ratio of the Unemployed and educated labor force (% of population) of High income: nonOECD in 2002 to that in 2006?
Your response must be concise. 0.9. What is the ratio of the Unemployed and educated labor force (% of population) of Korea (Republic) in 2002 to that in 2006?
Provide a succinct answer. 1. What is the ratio of the Unemployed and educated labor force (% of population) in Romania in 2002 to that in 2006?
Keep it short and to the point. 1.08. What is the ratio of the Unemployed and educated labor force (% of population) in Slovak Republic in 2002 to that in 2006?
Keep it short and to the point. 1.12. What is the ratio of the Unemployed and educated labor force (% of population) in High income: nonOECD in 2002 to that in 2007?
Your response must be concise. 0.89. What is the ratio of the Unemployed and educated labor force (% of population) of Korea (Republic) in 2002 to that in 2007?
Keep it short and to the point. 0.97. What is the ratio of the Unemployed and educated labor force (% of population) of Romania in 2002 to that in 2007?
Ensure brevity in your answer.  1.1. What is the ratio of the Unemployed and educated labor force (% of population) in Slovak Republic in 2002 to that in 2007?
Provide a short and direct response. 1.17. What is the ratio of the Unemployed and educated labor force (% of population) in High income: nonOECD in 2003 to that in 2004?
Provide a succinct answer. 0.97. What is the ratio of the Unemployed and educated labor force (% of population) in Korea (Republic) in 2003 to that in 2004?
Your answer should be compact. 1. What is the ratio of the Unemployed and educated labor force (% of population) in Romania in 2003 to that in 2004?
Provide a succinct answer. 1.06. What is the ratio of the Unemployed and educated labor force (% of population) of Slovak Republic in 2003 to that in 2004?
Your answer should be compact. 1.04. What is the ratio of the Unemployed and educated labor force (% of population) of High income: nonOECD in 2003 to that in 2005?
Your response must be concise. 0.95. What is the ratio of the Unemployed and educated labor force (% of population) of Korea (Republic) in 2003 to that in 2005?
Provide a succinct answer. 0.99. What is the ratio of the Unemployed and educated labor force (% of population) of Slovak Republic in 2003 to that in 2005?
Ensure brevity in your answer.  1.08. What is the ratio of the Unemployed and educated labor force (% of population) of High income: nonOECD in 2003 to that in 2006?
Your answer should be compact. 0.96. What is the ratio of the Unemployed and educated labor force (% of population) of Korea (Republic) in 2003 to that in 2006?
Provide a succinct answer. 1.03. What is the ratio of the Unemployed and educated labor force (% of population) in Romania in 2003 to that in 2006?
Give a very brief answer. 1.04. What is the ratio of the Unemployed and educated labor force (% of population) of Slovak Republic in 2003 to that in 2006?
Give a very brief answer. 1.08. What is the ratio of the Unemployed and educated labor force (% of population) of High income: nonOECD in 2003 to that in 2007?
Your response must be concise. 0.95. What is the ratio of the Unemployed and educated labor force (% of population) of Korea (Republic) in 2003 to that in 2007?
Provide a succinct answer. 1.01. What is the ratio of the Unemployed and educated labor force (% of population) in Romania in 2003 to that in 2007?
Make the answer very short. 1.05. What is the ratio of the Unemployed and educated labor force (% of population) in Slovak Republic in 2003 to that in 2007?
Your answer should be very brief. 1.13. What is the ratio of the Unemployed and educated labor force (% of population) of High income: nonOECD in 2004 to that in 2005?
Provide a short and direct response. 0.98. What is the ratio of the Unemployed and educated labor force (% of population) of Korea (Republic) in 2004 to that in 2005?
Provide a succinct answer. 0.99. What is the ratio of the Unemployed and educated labor force (% of population) of Romania in 2004 to that in 2005?
Ensure brevity in your answer.  0.95. What is the ratio of the Unemployed and educated labor force (% of population) of Slovak Republic in 2004 to that in 2005?
Keep it short and to the point. 1.04. What is the ratio of the Unemployed and educated labor force (% of population) of High income: nonOECD in 2004 to that in 2006?
Your answer should be compact. 1. What is the ratio of the Unemployed and educated labor force (% of population) in Korea (Republic) in 2004 to that in 2006?
Your answer should be very brief. 1.03. What is the ratio of the Unemployed and educated labor force (% of population) of Romania in 2004 to that in 2006?
Ensure brevity in your answer.  0.98. What is the ratio of the Unemployed and educated labor force (% of population) of Slovak Republic in 2004 to that in 2006?
Your response must be concise. 1.04. What is the ratio of the Unemployed and educated labor force (% of population) in Romania in 2004 to that in 2007?
Offer a terse response. 0.99. What is the ratio of the Unemployed and educated labor force (% of population) in Slovak Republic in 2004 to that in 2007?
Give a very brief answer. 1.09. What is the ratio of the Unemployed and educated labor force (% of population) of High income: nonOECD in 2005 to that in 2006?
Provide a succinct answer. 1.02. What is the ratio of the Unemployed and educated labor force (% of population) in Korea (Republic) in 2005 to that in 2006?
Make the answer very short. 1.04. What is the ratio of the Unemployed and educated labor force (% of population) in Romania in 2005 to that in 2006?
Your answer should be very brief. 1.03. What is the ratio of the Unemployed and educated labor force (% of population) in Slovak Republic in 2005 to that in 2006?
Give a very brief answer. 1. What is the ratio of the Unemployed and educated labor force (% of population) in High income: nonOECD in 2005 to that in 2007?
Your answer should be compact. 1.01. What is the ratio of the Unemployed and educated labor force (% of population) in Korea (Republic) in 2005 to that in 2007?
Give a very brief answer. 1.02. What is the ratio of the Unemployed and educated labor force (% of population) in Romania in 2005 to that in 2007?
Ensure brevity in your answer.  1.04. What is the ratio of the Unemployed and educated labor force (% of population) in Slovak Republic in 2005 to that in 2007?
Provide a succinct answer. 1.05. What is the ratio of the Unemployed and educated labor force (% of population) in High income: nonOECD in 2006 to that in 2007?
Keep it short and to the point. 0.99. What is the ratio of the Unemployed and educated labor force (% of population) of Korea (Republic) in 2006 to that in 2007?
Your answer should be very brief. 0.98. What is the ratio of the Unemployed and educated labor force (% of population) of Romania in 2006 to that in 2007?
Your answer should be very brief. 1.01. What is the ratio of the Unemployed and educated labor force (% of population) of Slovak Republic in 2006 to that in 2007?
Ensure brevity in your answer.  1.04. What is the difference between the highest and the second highest Unemployed and educated labor force (% of population) of High income: nonOECD?
Your response must be concise. 0.31. What is the difference between the highest and the second highest Unemployed and educated labor force (% of population) of Korea (Republic)?
Offer a very short reply. 0.6. What is the difference between the highest and the second highest Unemployed and educated labor force (% of population) in Romania?
Your response must be concise. 2. What is the difference between the highest and the lowest Unemployed and educated labor force (% of population) in High income: nonOECD?
Ensure brevity in your answer.  7.27. What is the difference between the highest and the lowest Unemployed and educated labor force (% of population) in Korea (Republic)?
Your response must be concise. 3.9. What is the difference between the highest and the lowest Unemployed and educated labor force (% of population) of Romania?
Your answer should be very brief. 10. What is the difference between the highest and the lowest Unemployed and educated labor force (% of population) in Slovak Republic?
Provide a short and direct response. 12.2. 